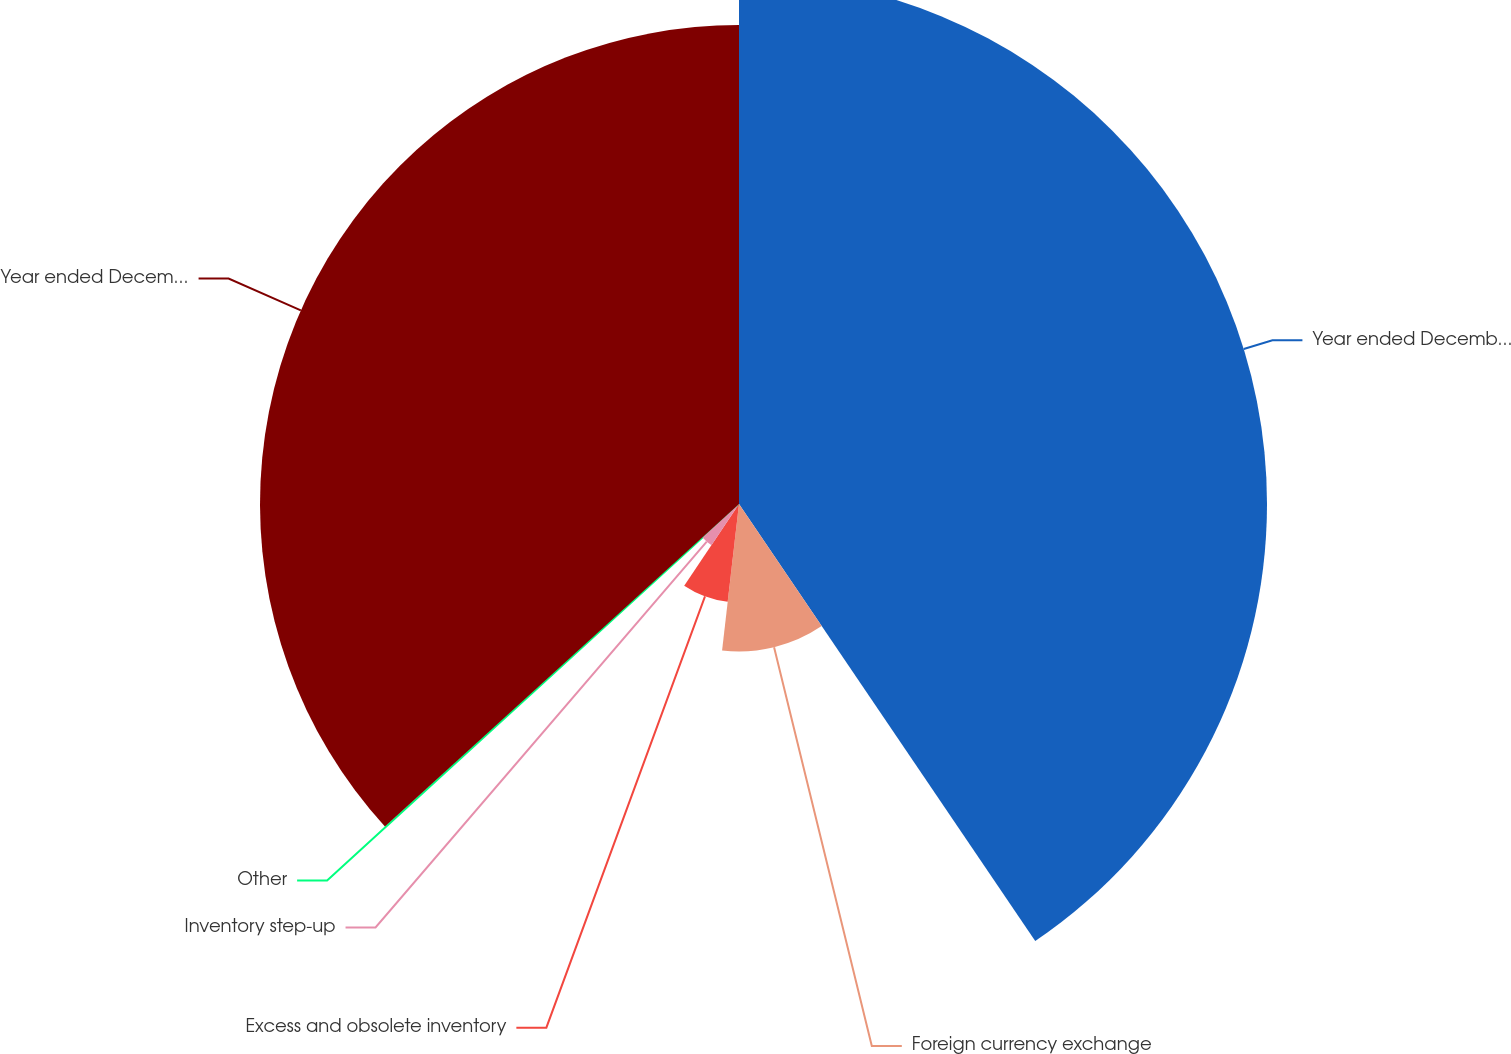Convert chart. <chart><loc_0><loc_0><loc_500><loc_500><pie_chart><fcel>Year ended December 31 2007<fcel>Foreign currency exchange<fcel>Excess and obsolete inventory<fcel>Inventory step-up<fcel>Other<fcel>Year ended December 31 2008<nl><fcel>40.52%<fcel>11.31%<fcel>7.56%<fcel>3.8%<fcel>0.05%<fcel>36.76%<nl></chart> 